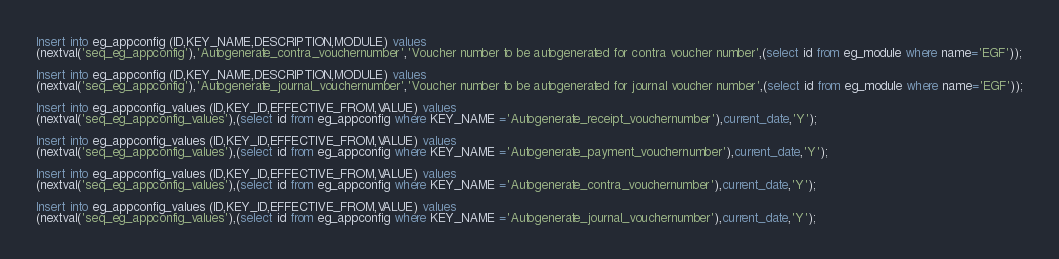Convert code to text. <code><loc_0><loc_0><loc_500><loc_500><_SQL_>
Insert into eg_appconfig (ID,KEY_NAME,DESCRIPTION,MODULE) values 
(nextval('seq_eg_appconfig'),'Autogenerate_contra_vouchernumber','Voucher number to be autogenerated for contra voucher number',(select id from eg_module where name='EGF'));

Insert into eg_appconfig (ID,KEY_NAME,DESCRIPTION,MODULE) values 
(nextval('seq_eg_appconfig'),'Autogenerate_journal_vouchernumber','Voucher number to be autogenerated for journal voucher number',(select id from eg_module where name='EGF'));

Insert into eg_appconfig_values (ID,KEY_ID,EFFECTIVE_FROM,VALUE) values 
(nextval('seq_eg_appconfig_values'),(select id from eg_appconfig where KEY_NAME ='Autogenerate_receipt_vouchernumber'),current_date,'Y');

Insert into eg_appconfig_values (ID,KEY_ID,EFFECTIVE_FROM,VALUE) values 
(nextval('seq_eg_appconfig_values'),(select id from eg_appconfig where KEY_NAME ='Autogenerate_payment_vouchernumber'),current_date,'Y');

Insert into eg_appconfig_values (ID,KEY_ID,EFFECTIVE_FROM,VALUE) values 
(nextval('seq_eg_appconfig_values'),(select id from eg_appconfig where KEY_NAME ='Autogenerate_contra_vouchernumber'),current_date,'Y');

Insert into eg_appconfig_values (ID,KEY_ID,EFFECTIVE_FROM,VALUE) values 
(nextval('seq_eg_appconfig_values'),(select id from eg_appconfig where KEY_NAME ='Autogenerate_journal_vouchernumber'),current_date,'Y');</code> 